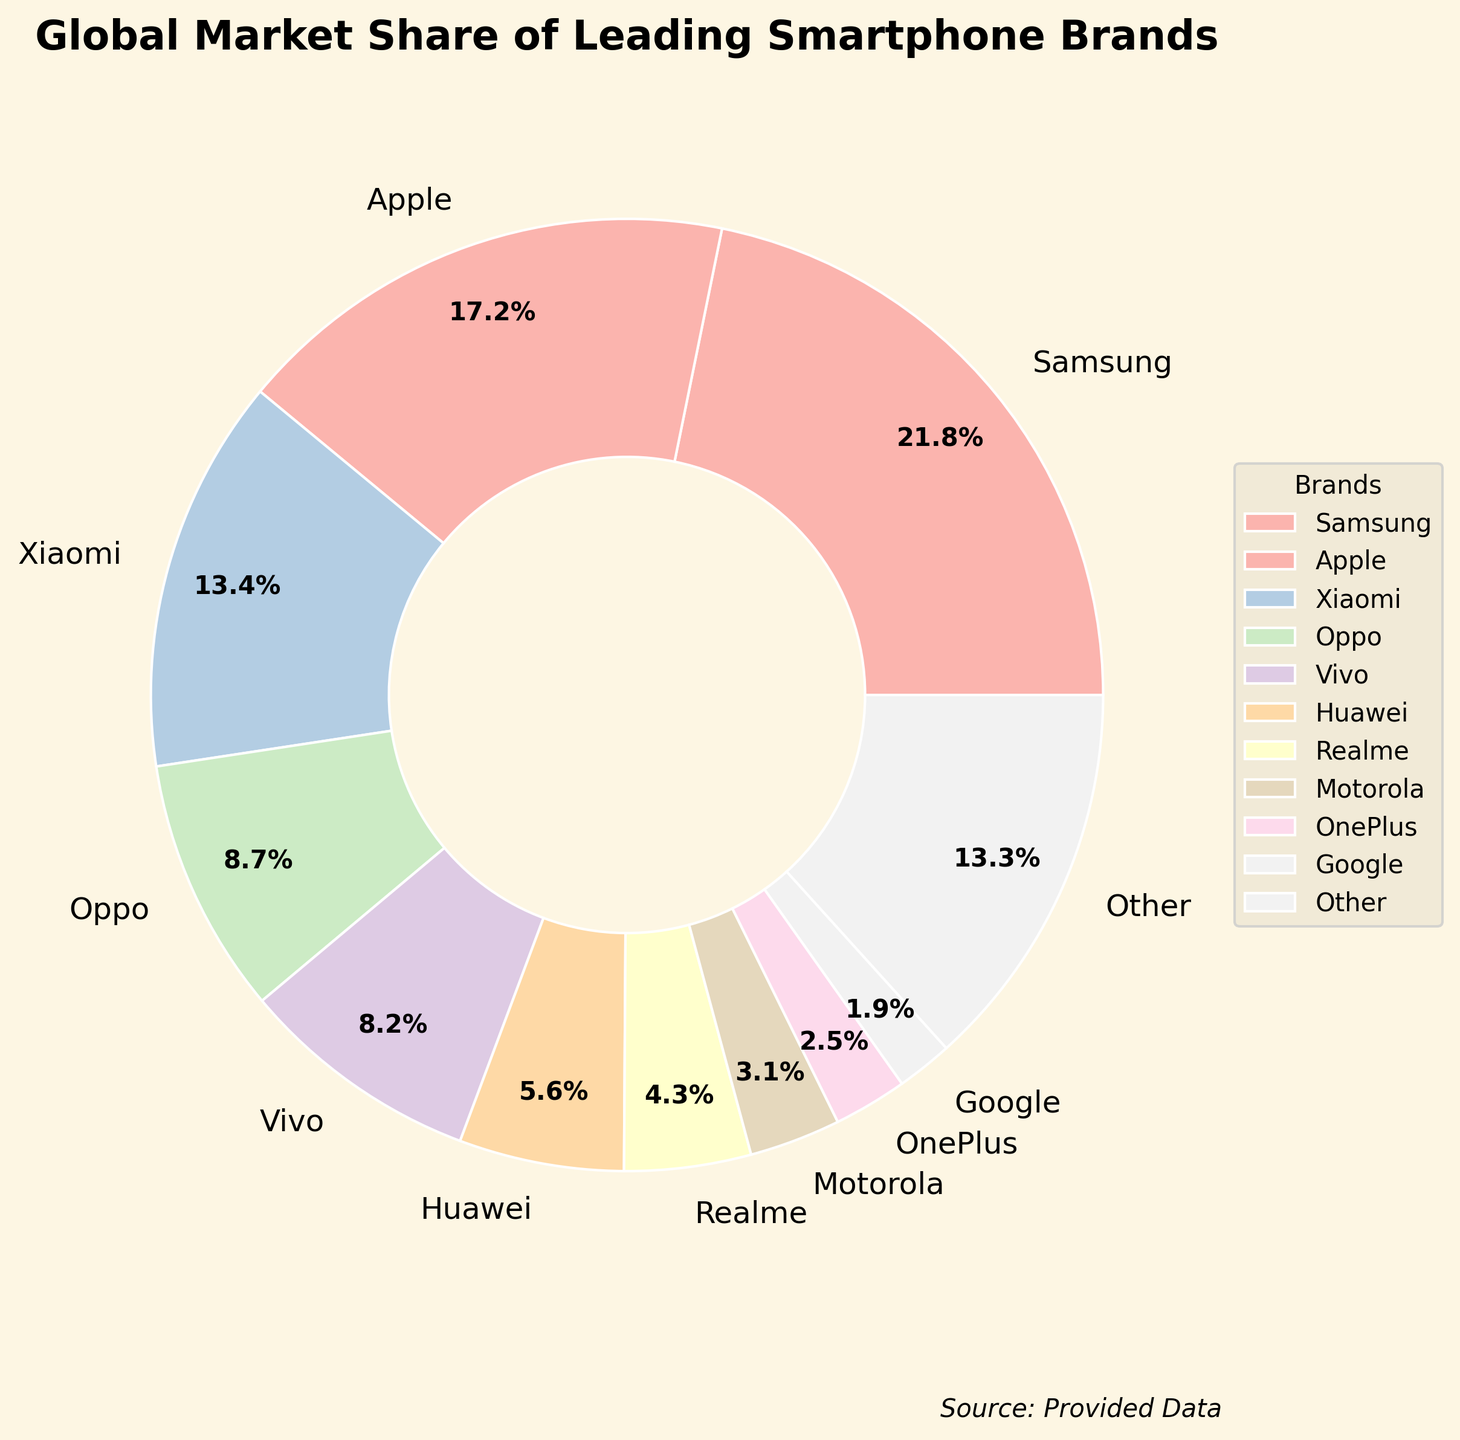What is the combined market share of Samsung and Apple? Add the individual market shares of Samsung and Apple. Samsung has a market share of 21.8% and Apple has 17.2%. Their combined market share is 21.8% + 17.2% = 39%.
Answer: 39% Which brand has the smallest market share? Look at the labels of the pie chart and find the one with the smallest percentage. Google has the smallest market share of 1.9%.
Answer: Google How does the market share of Xiaomi compare to that of Oppo and Vivo combined? Xiaomi has a market share of 13.4%. Oppo's market share is 8.7%, and Vivo's is 8.2%. Combined, Oppo and Vivo have 8.7% + 8.2% = 16.9%. Xiaomi's market share is smaller than the combined market share of Oppo and Vivo.
Answer: Smaller What percentage of the market is captured by brands with less than 10% share individually? Identify brands with less than 10% market share: Oppo (8.7%), Vivo (8.2%), Huawei (5.6%), Realme (4.3%), Motorola (3.1%), OnePlus (2.5%), and Google (1.9%). Sum their market shares: 8.7% + 8.2% + 5.6% + 4.3% + 3.1% + 2.5% + 1.9% = 34.3%.
Answer: 34.3% What is the difference in market share between Vivo and Huawei? Subtract Huawei's market share from Vivo's market share. Vivo has 8.2% and Huawei has 5.6%. The difference is 8.2% - 5.6% = 2.6%.
Answer: 2.6% How many brands have a market share greater than 10%? Look at the pie chart and count the number of brands with market shares greater than 10%. The brands are Samsung (21.8%), Apple (17.2%), and Xiaomi (13.4%), totaling 3 brands.
Answer: 3 Which two brands combined capture almost the same market share as 'Other' brands? Identify individual market shares and find a combination close to 'Other' which is 13.3%. Oppo (8.7%) and Vivo (8.2%) together make 8.7% + 8.2% = 16.9%, which is more than 'Other'. Xiaomi (13.4%) alone is very close, but combining Vivo (8.2%) and Huawei (5.6%) gives us 8.2% + 5.6% = 13.8%. 13.8% is the closest combination.
Answer: Vivo and Huawei What is the visual representation style used in the pie chart? Observe the visual style of the pie chart. The style used is 'Solarize_Light2'.
Answer: Solarize_Light2 Which brand is represented by the color closest to the start of the color gradient? Given the way colors are mapped in pie charts, typically the first listed brand (Samsung) will use the first color in the gradient. Therefore, Samsung is represented by the color closest to the start of the color gradient.
Answer: Samsung 